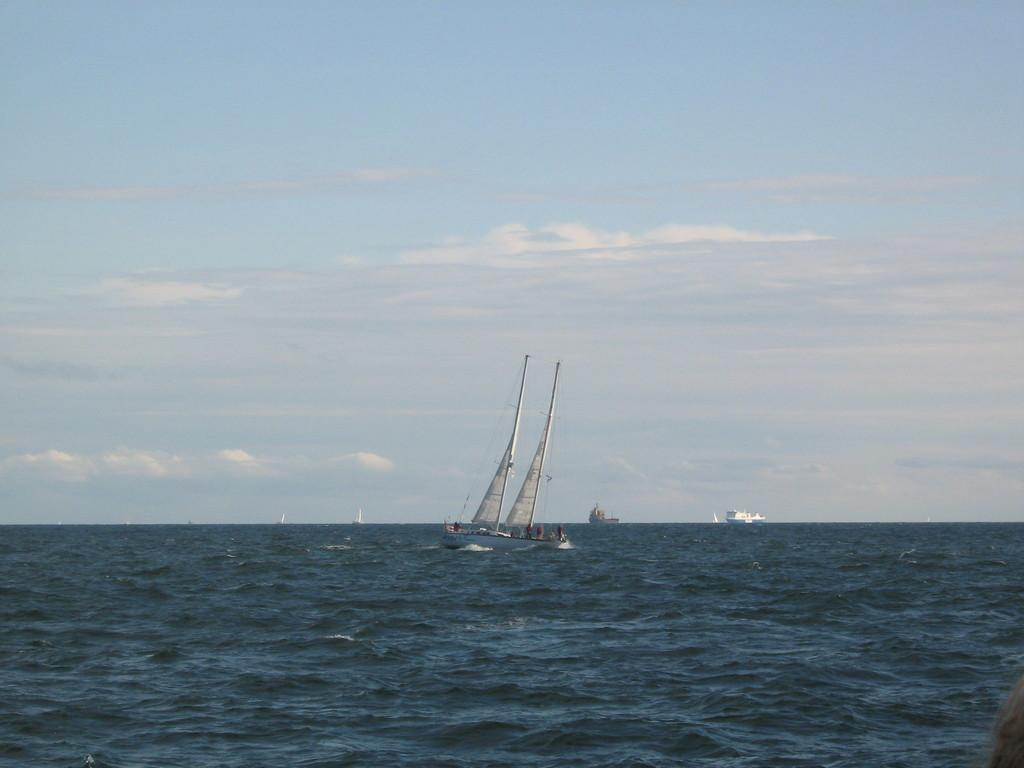What is present in the image? There is water in the image. What is floating on the water? There are boats on the water. What can be seen in the background of the image? The sky is visible in the background of the image. What is the condition of the sky in the image? There are clouds in the sky. What type of corn can be seen growing on the boats in the image? There is no corn present in the image, and the boats do not have any growing on them. 